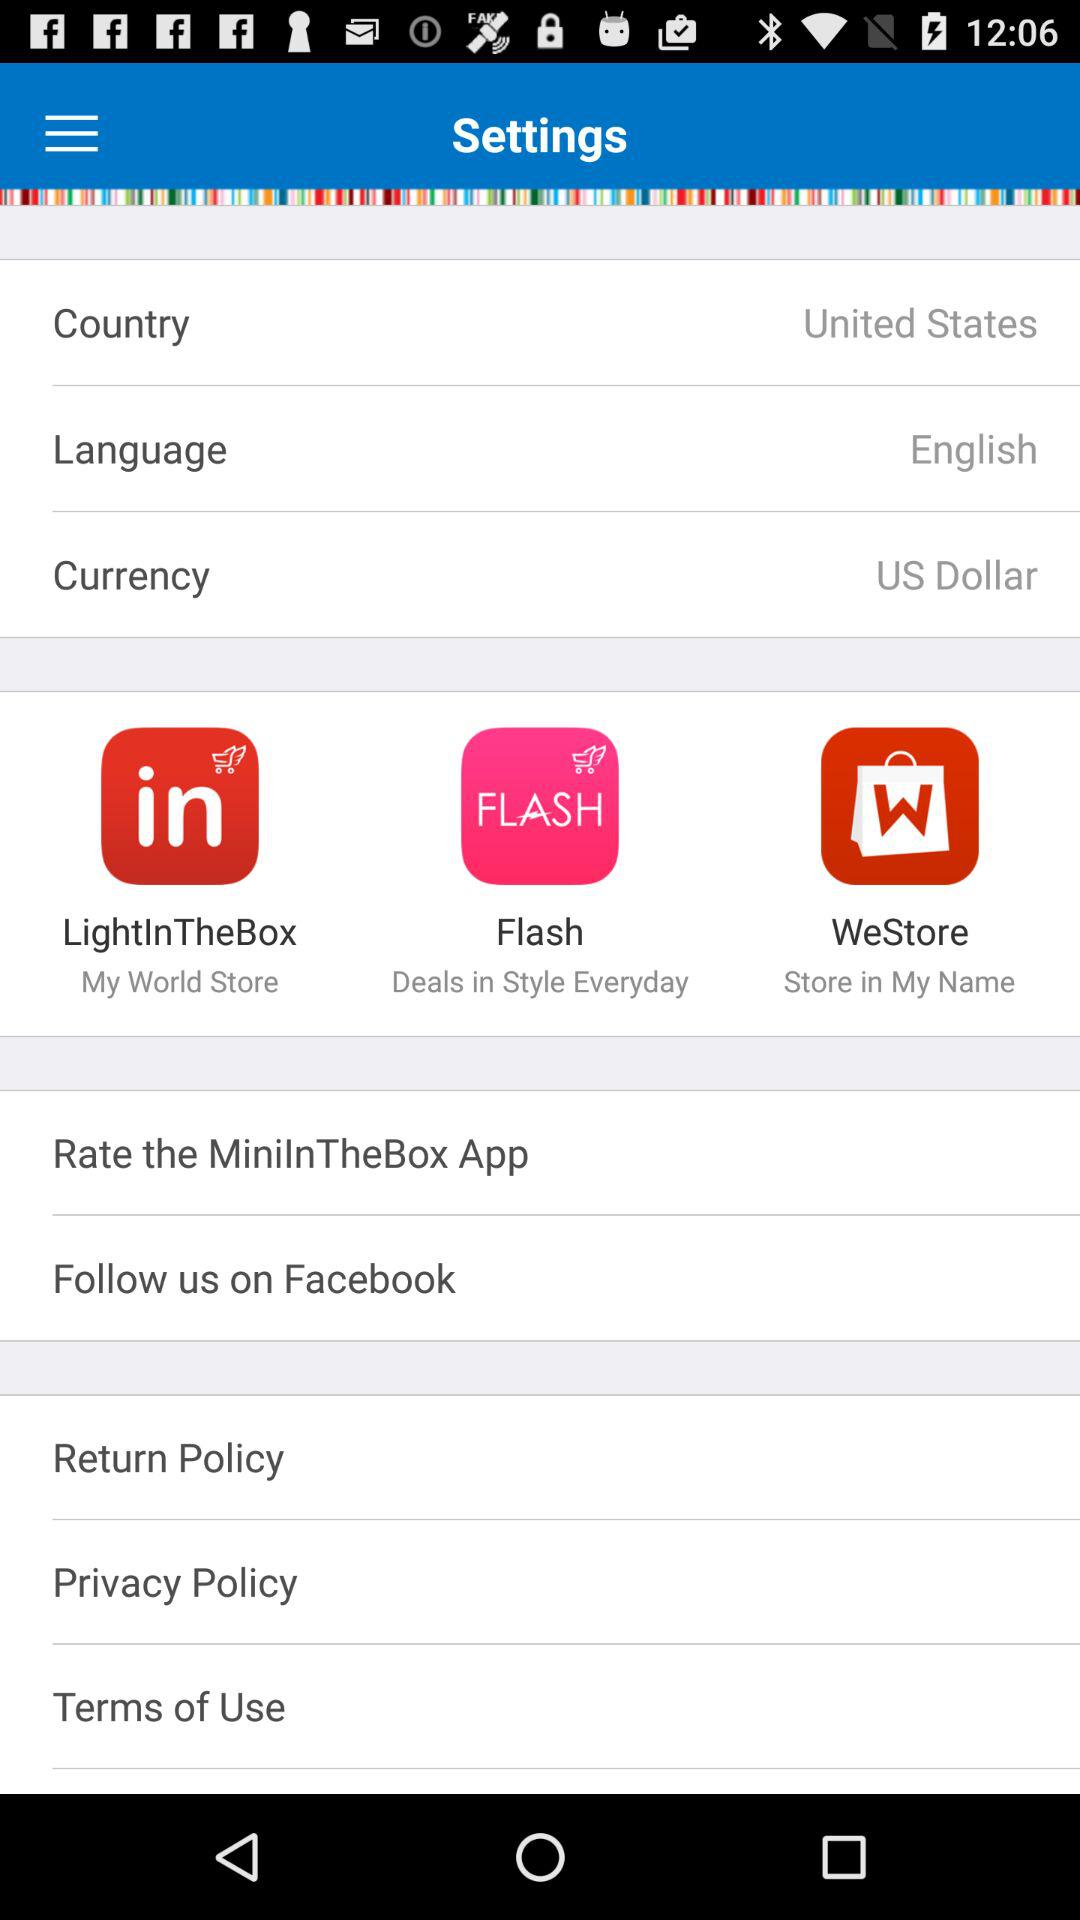Which language is selected? The selected language is English. 